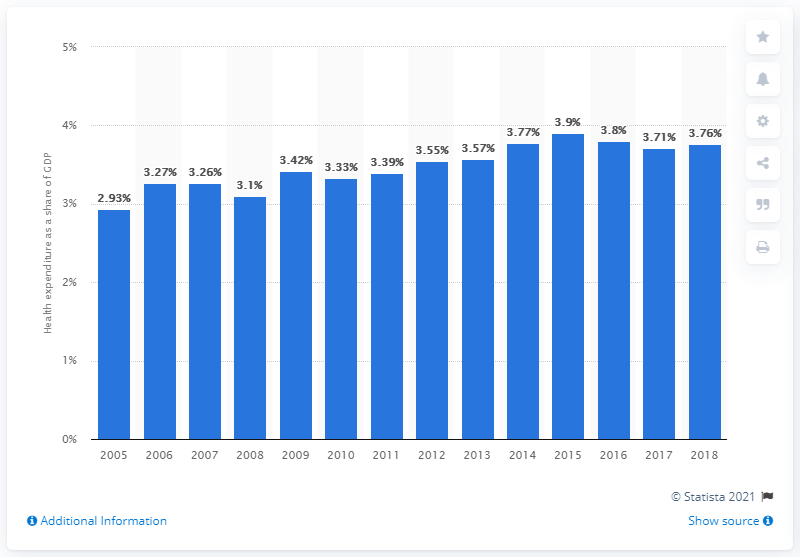Specify some key components in this picture. In 2015, Malaysia's maximum health expenditure was 3.9%. In 2018, Malaysia's health expenditure accounted for 3.8% of its Gross Domestic Product (GDP). 